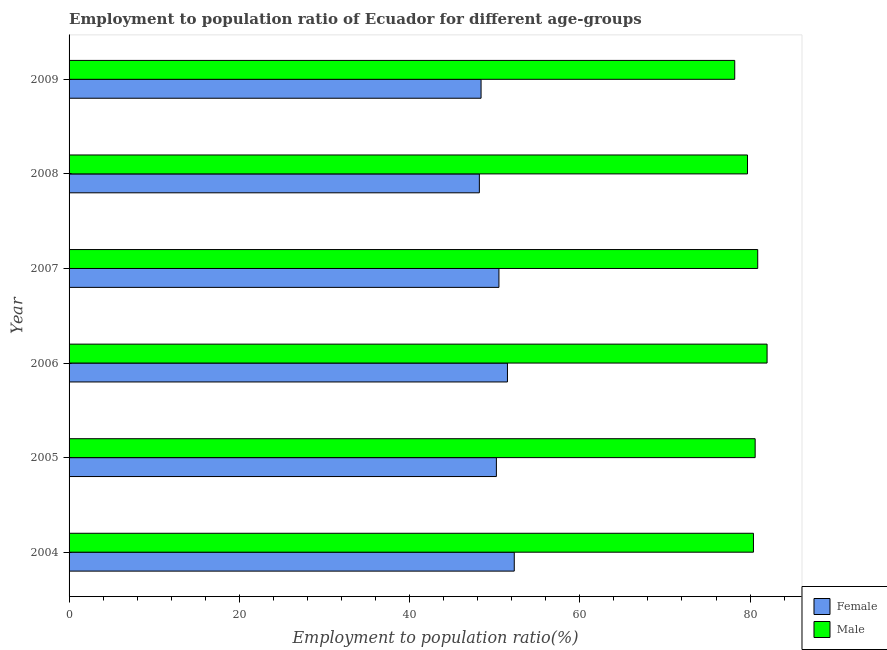Are the number of bars on each tick of the Y-axis equal?
Your answer should be very brief. Yes. How many bars are there on the 5th tick from the top?
Give a very brief answer. 2. How many bars are there on the 1st tick from the bottom?
Offer a very short reply. 2. What is the label of the 5th group of bars from the top?
Offer a terse response. 2005. In how many cases, is the number of bars for a given year not equal to the number of legend labels?
Provide a short and direct response. 0. What is the employment to population ratio(female) in 2009?
Provide a short and direct response. 48.4. Across all years, what is the maximum employment to population ratio(female)?
Give a very brief answer. 52.3. Across all years, what is the minimum employment to population ratio(male)?
Offer a very short reply. 78.2. In which year was the employment to population ratio(male) maximum?
Ensure brevity in your answer.  2006. What is the total employment to population ratio(male) in the graph?
Provide a short and direct response. 481.8. What is the difference between the employment to population ratio(male) in 2009 and the employment to population ratio(female) in 2006?
Offer a terse response. 26.7. What is the average employment to population ratio(male) per year?
Provide a succinct answer. 80.3. In the year 2006, what is the difference between the employment to population ratio(male) and employment to population ratio(female)?
Offer a terse response. 30.5. In how many years, is the employment to population ratio(male) greater than 28 %?
Keep it short and to the point. 6. What is the ratio of the employment to population ratio(male) in 2006 to that in 2008?
Provide a short and direct response. 1.03. Is the difference between the employment to population ratio(male) in 2006 and 2007 greater than the difference between the employment to population ratio(female) in 2006 and 2007?
Make the answer very short. Yes. Is the sum of the employment to population ratio(male) in 2007 and 2008 greater than the maximum employment to population ratio(female) across all years?
Provide a succinct answer. Yes. What does the 2nd bar from the top in 2004 represents?
Give a very brief answer. Female. What does the 1st bar from the bottom in 2009 represents?
Your answer should be compact. Female. How many bars are there?
Provide a succinct answer. 12. Does the graph contain grids?
Your answer should be compact. No. How many legend labels are there?
Your answer should be compact. 2. How are the legend labels stacked?
Your response must be concise. Vertical. What is the title of the graph?
Make the answer very short. Employment to population ratio of Ecuador for different age-groups. Does "Secondary" appear as one of the legend labels in the graph?
Offer a very short reply. No. What is the Employment to population ratio(%) of Female in 2004?
Ensure brevity in your answer.  52.3. What is the Employment to population ratio(%) in Male in 2004?
Your response must be concise. 80.4. What is the Employment to population ratio(%) of Female in 2005?
Provide a succinct answer. 50.2. What is the Employment to population ratio(%) of Male in 2005?
Keep it short and to the point. 80.6. What is the Employment to population ratio(%) in Female in 2006?
Your response must be concise. 51.5. What is the Employment to population ratio(%) of Male in 2006?
Your answer should be compact. 82. What is the Employment to population ratio(%) in Female in 2007?
Ensure brevity in your answer.  50.5. What is the Employment to population ratio(%) of Male in 2007?
Make the answer very short. 80.9. What is the Employment to population ratio(%) in Female in 2008?
Your answer should be compact. 48.2. What is the Employment to population ratio(%) of Male in 2008?
Offer a terse response. 79.7. What is the Employment to population ratio(%) in Female in 2009?
Ensure brevity in your answer.  48.4. What is the Employment to population ratio(%) of Male in 2009?
Give a very brief answer. 78.2. Across all years, what is the maximum Employment to population ratio(%) in Female?
Offer a terse response. 52.3. Across all years, what is the minimum Employment to population ratio(%) of Female?
Offer a very short reply. 48.2. Across all years, what is the minimum Employment to population ratio(%) of Male?
Give a very brief answer. 78.2. What is the total Employment to population ratio(%) in Female in the graph?
Keep it short and to the point. 301.1. What is the total Employment to population ratio(%) of Male in the graph?
Your answer should be very brief. 481.8. What is the difference between the Employment to population ratio(%) in Male in 2004 and that in 2007?
Your answer should be very brief. -0.5. What is the difference between the Employment to population ratio(%) of Female in 2004 and that in 2008?
Your answer should be very brief. 4.1. What is the difference between the Employment to population ratio(%) in Male in 2004 and that in 2008?
Keep it short and to the point. 0.7. What is the difference between the Employment to population ratio(%) of Female in 2005 and that in 2006?
Your answer should be very brief. -1.3. What is the difference between the Employment to population ratio(%) of Female in 2005 and that in 2007?
Your answer should be very brief. -0.3. What is the difference between the Employment to population ratio(%) in Male in 2005 and that in 2007?
Ensure brevity in your answer.  -0.3. What is the difference between the Employment to population ratio(%) of Female in 2005 and that in 2009?
Make the answer very short. 1.8. What is the difference between the Employment to population ratio(%) of Male in 2005 and that in 2009?
Ensure brevity in your answer.  2.4. What is the difference between the Employment to population ratio(%) of Female in 2006 and that in 2007?
Keep it short and to the point. 1. What is the difference between the Employment to population ratio(%) in Male in 2006 and that in 2007?
Offer a terse response. 1.1. What is the difference between the Employment to population ratio(%) of Female in 2006 and that in 2008?
Provide a succinct answer. 3.3. What is the difference between the Employment to population ratio(%) in Male in 2006 and that in 2009?
Give a very brief answer. 3.8. What is the difference between the Employment to population ratio(%) in Male in 2007 and that in 2008?
Offer a terse response. 1.2. What is the difference between the Employment to population ratio(%) of Male in 2007 and that in 2009?
Keep it short and to the point. 2.7. What is the difference between the Employment to population ratio(%) of Female in 2004 and the Employment to population ratio(%) of Male in 2005?
Make the answer very short. -28.3. What is the difference between the Employment to population ratio(%) of Female in 2004 and the Employment to population ratio(%) of Male in 2006?
Your answer should be compact. -29.7. What is the difference between the Employment to population ratio(%) of Female in 2004 and the Employment to population ratio(%) of Male in 2007?
Offer a terse response. -28.6. What is the difference between the Employment to population ratio(%) in Female in 2004 and the Employment to population ratio(%) in Male in 2008?
Provide a short and direct response. -27.4. What is the difference between the Employment to population ratio(%) in Female in 2004 and the Employment to population ratio(%) in Male in 2009?
Offer a terse response. -25.9. What is the difference between the Employment to population ratio(%) in Female in 2005 and the Employment to population ratio(%) in Male in 2006?
Give a very brief answer. -31.8. What is the difference between the Employment to population ratio(%) in Female in 2005 and the Employment to population ratio(%) in Male in 2007?
Provide a succinct answer. -30.7. What is the difference between the Employment to population ratio(%) in Female in 2005 and the Employment to population ratio(%) in Male in 2008?
Keep it short and to the point. -29.5. What is the difference between the Employment to population ratio(%) in Female in 2005 and the Employment to population ratio(%) in Male in 2009?
Give a very brief answer. -28. What is the difference between the Employment to population ratio(%) of Female in 2006 and the Employment to population ratio(%) of Male in 2007?
Keep it short and to the point. -29.4. What is the difference between the Employment to population ratio(%) in Female in 2006 and the Employment to population ratio(%) in Male in 2008?
Provide a succinct answer. -28.2. What is the difference between the Employment to population ratio(%) of Female in 2006 and the Employment to population ratio(%) of Male in 2009?
Provide a succinct answer. -26.7. What is the difference between the Employment to population ratio(%) of Female in 2007 and the Employment to population ratio(%) of Male in 2008?
Provide a succinct answer. -29.2. What is the difference between the Employment to population ratio(%) of Female in 2007 and the Employment to population ratio(%) of Male in 2009?
Offer a very short reply. -27.7. What is the difference between the Employment to population ratio(%) of Female in 2008 and the Employment to population ratio(%) of Male in 2009?
Give a very brief answer. -30. What is the average Employment to population ratio(%) in Female per year?
Keep it short and to the point. 50.18. What is the average Employment to population ratio(%) in Male per year?
Your answer should be very brief. 80.3. In the year 2004, what is the difference between the Employment to population ratio(%) of Female and Employment to population ratio(%) of Male?
Offer a very short reply. -28.1. In the year 2005, what is the difference between the Employment to population ratio(%) of Female and Employment to population ratio(%) of Male?
Your answer should be very brief. -30.4. In the year 2006, what is the difference between the Employment to population ratio(%) in Female and Employment to population ratio(%) in Male?
Ensure brevity in your answer.  -30.5. In the year 2007, what is the difference between the Employment to population ratio(%) in Female and Employment to population ratio(%) in Male?
Your answer should be very brief. -30.4. In the year 2008, what is the difference between the Employment to population ratio(%) of Female and Employment to population ratio(%) of Male?
Your answer should be very brief. -31.5. In the year 2009, what is the difference between the Employment to population ratio(%) of Female and Employment to population ratio(%) of Male?
Your answer should be very brief. -29.8. What is the ratio of the Employment to population ratio(%) of Female in 2004 to that in 2005?
Provide a short and direct response. 1.04. What is the ratio of the Employment to population ratio(%) of Male in 2004 to that in 2005?
Offer a very short reply. 1. What is the ratio of the Employment to population ratio(%) of Female in 2004 to that in 2006?
Provide a short and direct response. 1.02. What is the ratio of the Employment to population ratio(%) of Male in 2004 to that in 2006?
Keep it short and to the point. 0.98. What is the ratio of the Employment to population ratio(%) in Female in 2004 to that in 2007?
Make the answer very short. 1.04. What is the ratio of the Employment to population ratio(%) of Male in 2004 to that in 2007?
Offer a terse response. 0.99. What is the ratio of the Employment to population ratio(%) of Female in 2004 to that in 2008?
Ensure brevity in your answer.  1.09. What is the ratio of the Employment to population ratio(%) in Male in 2004 to that in 2008?
Make the answer very short. 1.01. What is the ratio of the Employment to population ratio(%) in Female in 2004 to that in 2009?
Provide a succinct answer. 1.08. What is the ratio of the Employment to population ratio(%) in Male in 2004 to that in 2009?
Provide a short and direct response. 1.03. What is the ratio of the Employment to population ratio(%) in Female in 2005 to that in 2006?
Your answer should be very brief. 0.97. What is the ratio of the Employment to population ratio(%) of Male in 2005 to that in 2006?
Your answer should be very brief. 0.98. What is the ratio of the Employment to population ratio(%) in Female in 2005 to that in 2007?
Make the answer very short. 0.99. What is the ratio of the Employment to population ratio(%) of Male in 2005 to that in 2007?
Keep it short and to the point. 1. What is the ratio of the Employment to population ratio(%) in Female in 2005 to that in 2008?
Make the answer very short. 1.04. What is the ratio of the Employment to population ratio(%) in Male in 2005 to that in 2008?
Make the answer very short. 1.01. What is the ratio of the Employment to population ratio(%) of Female in 2005 to that in 2009?
Keep it short and to the point. 1.04. What is the ratio of the Employment to population ratio(%) in Male in 2005 to that in 2009?
Your response must be concise. 1.03. What is the ratio of the Employment to population ratio(%) in Female in 2006 to that in 2007?
Offer a very short reply. 1.02. What is the ratio of the Employment to population ratio(%) of Male in 2006 to that in 2007?
Your answer should be very brief. 1.01. What is the ratio of the Employment to population ratio(%) of Female in 2006 to that in 2008?
Give a very brief answer. 1.07. What is the ratio of the Employment to population ratio(%) of Male in 2006 to that in 2008?
Provide a short and direct response. 1.03. What is the ratio of the Employment to population ratio(%) in Female in 2006 to that in 2009?
Provide a succinct answer. 1.06. What is the ratio of the Employment to population ratio(%) of Male in 2006 to that in 2009?
Provide a short and direct response. 1.05. What is the ratio of the Employment to population ratio(%) in Female in 2007 to that in 2008?
Give a very brief answer. 1.05. What is the ratio of the Employment to population ratio(%) in Male in 2007 to that in 2008?
Offer a very short reply. 1.02. What is the ratio of the Employment to population ratio(%) of Female in 2007 to that in 2009?
Keep it short and to the point. 1.04. What is the ratio of the Employment to population ratio(%) in Male in 2007 to that in 2009?
Your answer should be compact. 1.03. What is the ratio of the Employment to population ratio(%) in Male in 2008 to that in 2009?
Your response must be concise. 1.02. What is the difference between the highest and the second highest Employment to population ratio(%) in Female?
Provide a succinct answer. 0.8. What is the difference between the highest and the second highest Employment to population ratio(%) of Male?
Give a very brief answer. 1.1. What is the difference between the highest and the lowest Employment to population ratio(%) of Male?
Provide a short and direct response. 3.8. 